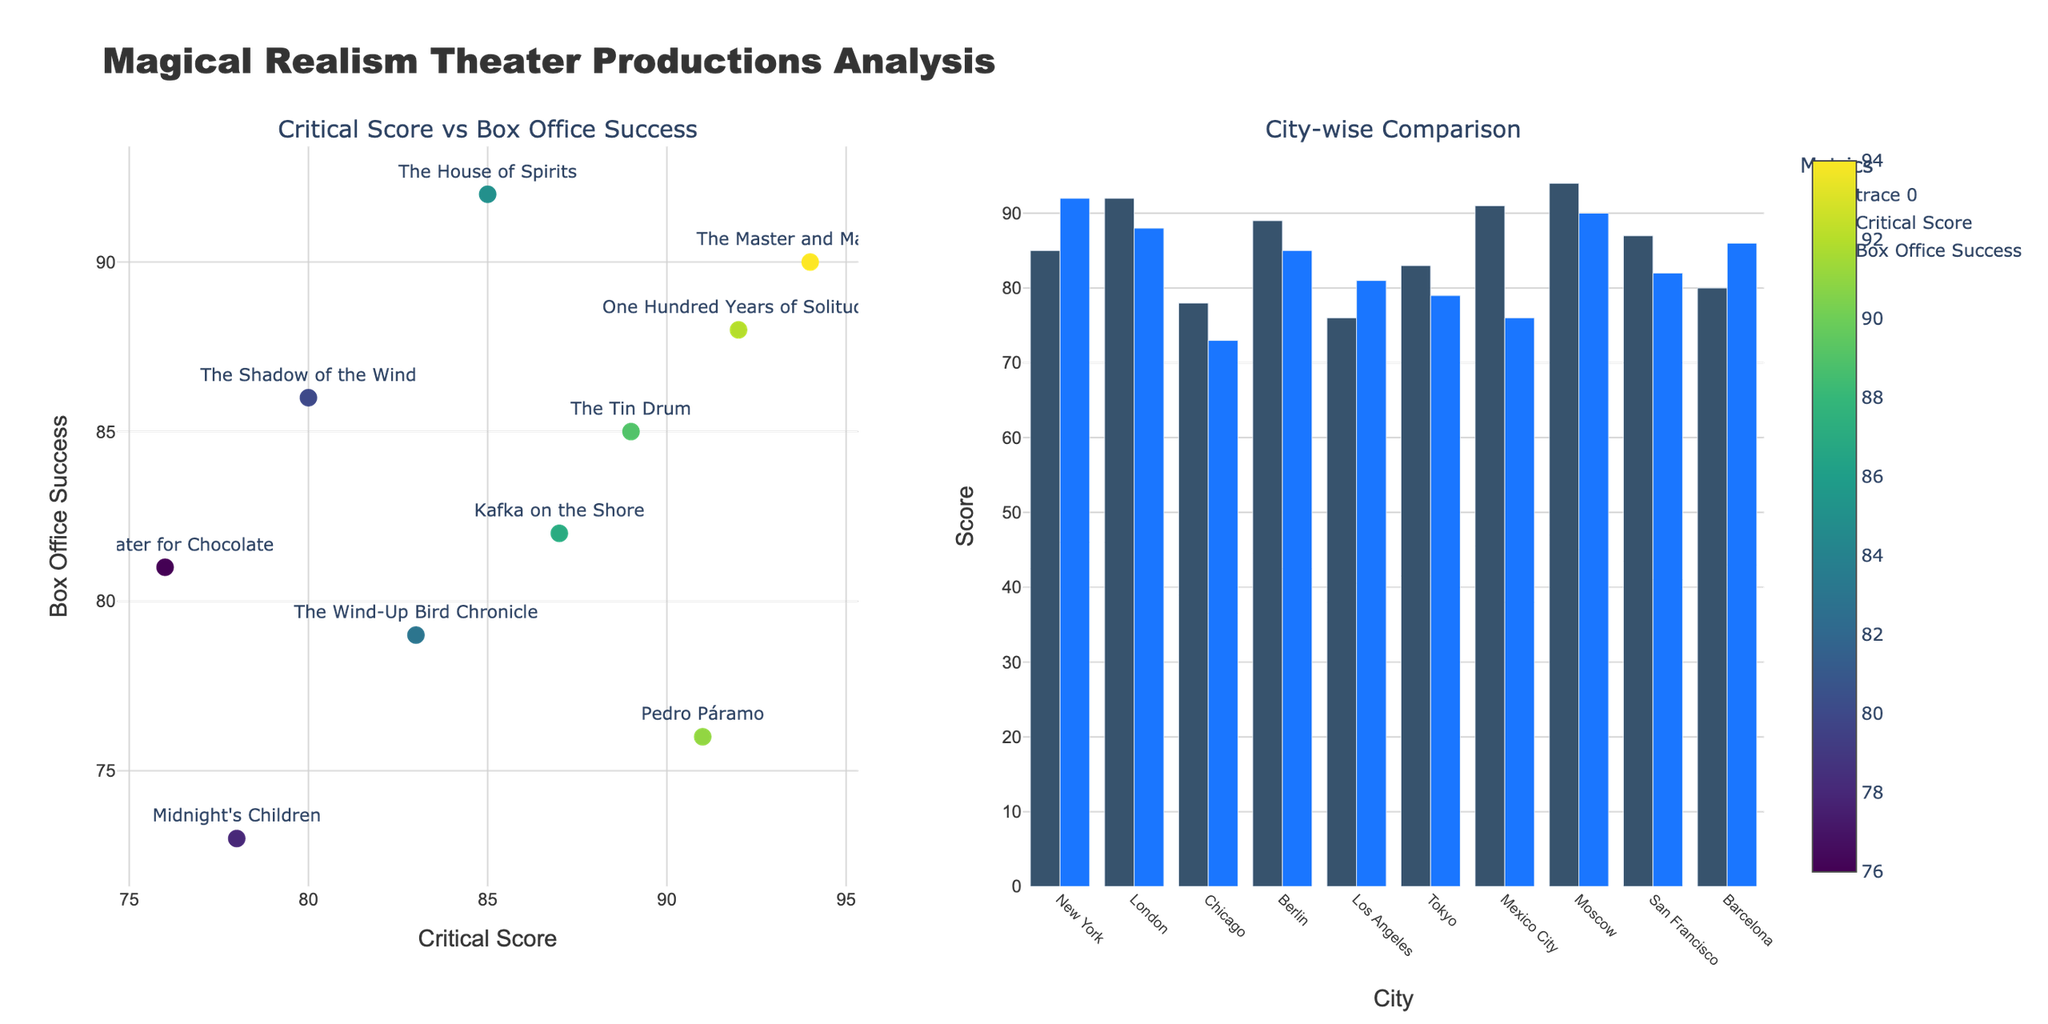What's the total vocal range in octaves for Sherine, Umm Kulthum, and Fairuz combined? Sherine's vocal range is 3.5 octaves, Umm Kulthum's is 3.0 octaves, and Fairuz's is 3.2 octaves. Adding these together, 3.5 + 3.0 + 3.2 = 9.7.
Answer: 9.7 Which vocalist has the highest melisma usage, and what is their score? Looking at the subplot for Melisma Usage, Sherine has a score of 9, which is the highest.
Answer: Sherine, 9 How does Sherine's vibrato intensity compare to Assala Nasri's? Sherine has a vibrato intensity of 7, whereas Assala Nasri has a vibrato intensity of 8.
Answer: Sherine's is lower Which vocalist's emotional delivery is most similar to Majida El Roumi's? Majida El Roumi has an emotional delivery score of 9. Angham also has an emotional delivery score of 9, making them most similar.
Answer: Angham What's the average vibrato intensity for Sherine, Elissa, and Nancy Ajram? Sherine's vibrato intensity is 7, Elissa's is 7, and Nancy Ajram's is 6. The average is (7 + 7 + 6) / 3 = 6.67.
Answer: 6.67 If we rank vocalists by vocal range, who is in the middle? The vocal ranges are 3.5, 3.4, 3.3, 3.3, 3.2, 3.2, 3.1, 3.1, 3.0, 3.0. Sorting these, the middle (5th and 6th) values are 3.2 and 3.2. Thus, Amal Maher and Fairuz, who have 3.2 octaves, are in the middle.
Answer: Amal Maher and Fairuz What is the difference in emotional delivery scores between Sherine and Fairuz? Sherine has an emotional delivery of 10, and Fairuz has a score of 8. The difference is 10 - 8 = 2.
Answer: 2 Who has a higher melisma usage, Umm Kulthum or Angham? Umm Kulthum has a melisma usage of 8, while Angham has a melisma usage of 8 as well. They have the same score.
Answer: Same Which vocalist has the lowest vibrato intensity? Looking at the subplot for Vibrato Intensity, Fairuz has the lowest score of 5.
Answer: Fairuz 